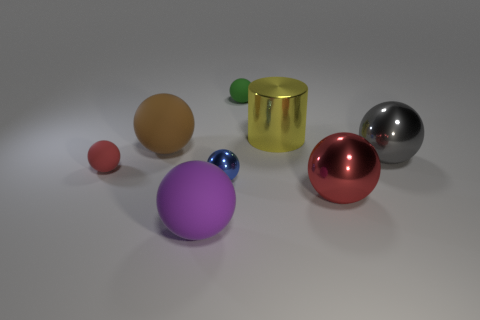Subtract 2 balls. How many balls are left? 5 Subtract all big brown spheres. How many spheres are left? 6 Subtract all green spheres. How many spheres are left? 6 Subtract all blue spheres. Subtract all gray cylinders. How many spheres are left? 6 Add 2 small green rubber things. How many objects exist? 10 Subtract all spheres. How many objects are left? 1 Add 1 large purple matte spheres. How many large purple matte spheres exist? 2 Subtract 0 yellow blocks. How many objects are left? 8 Subtract all shiny objects. Subtract all big yellow cylinders. How many objects are left? 3 Add 2 gray balls. How many gray balls are left? 3 